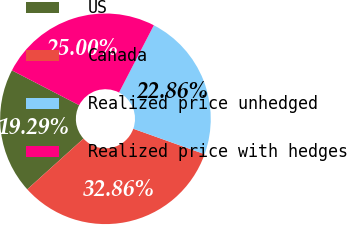<chart> <loc_0><loc_0><loc_500><loc_500><pie_chart><fcel>US<fcel>Canada<fcel>Realized price unhedged<fcel>Realized price with hedges<nl><fcel>19.29%<fcel>32.86%<fcel>22.86%<fcel>25.0%<nl></chart> 